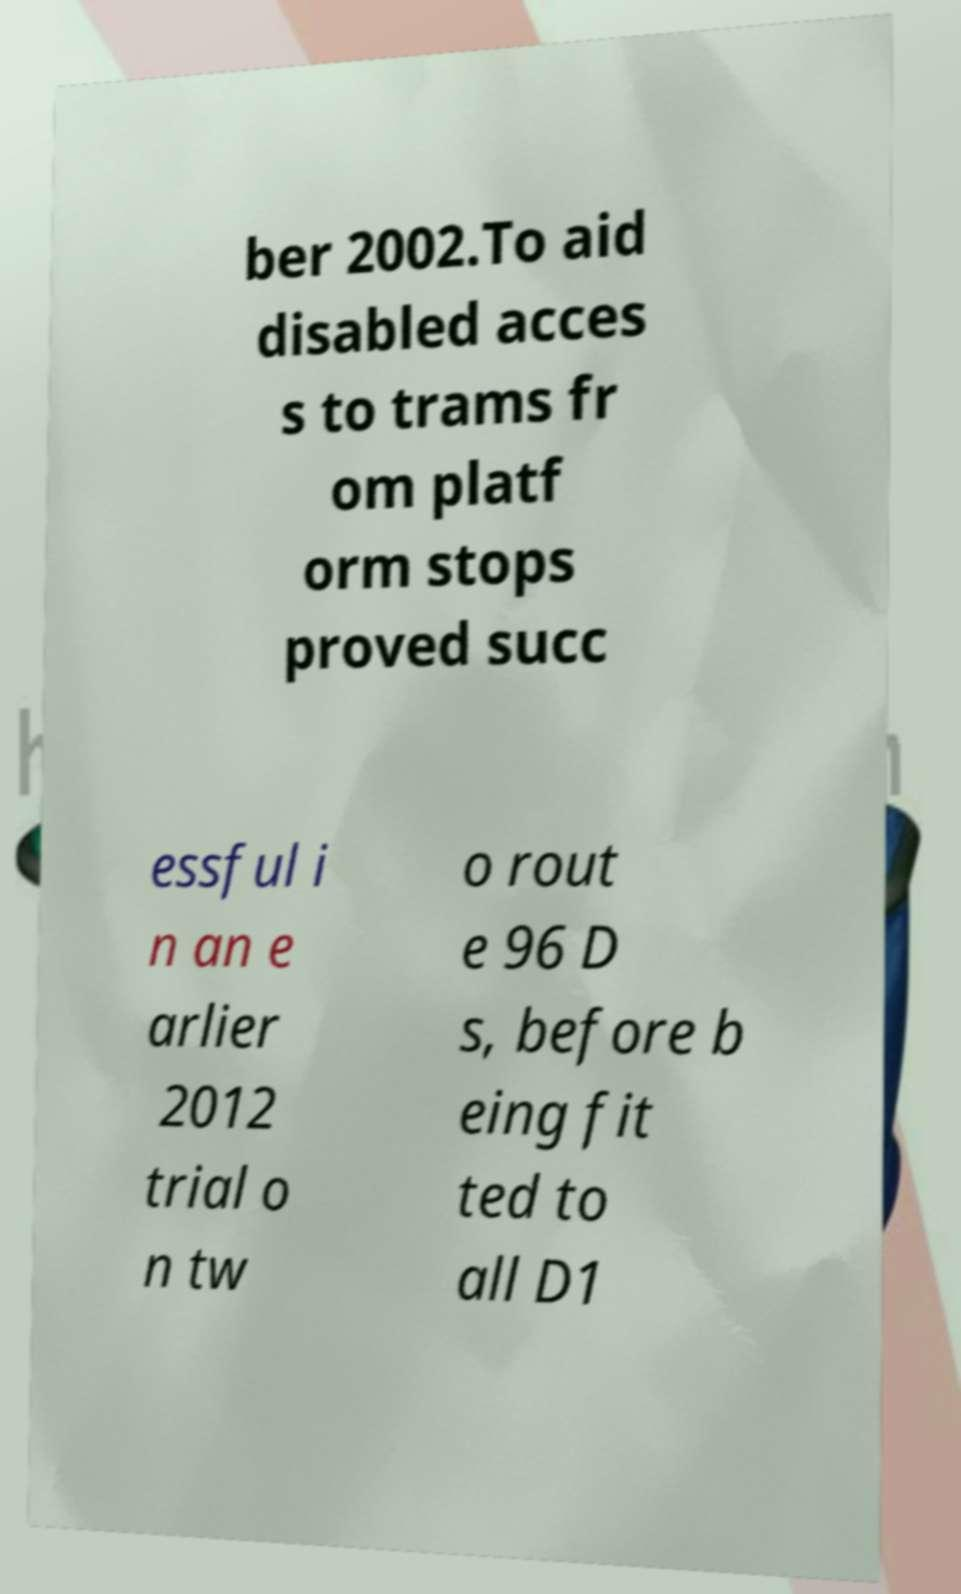Could you extract and type out the text from this image? ber 2002.To aid disabled acces s to trams fr om platf orm stops proved succ essful i n an e arlier 2012 trial o n tw o rout e 96 D s, before b eing fit ted to all D1 